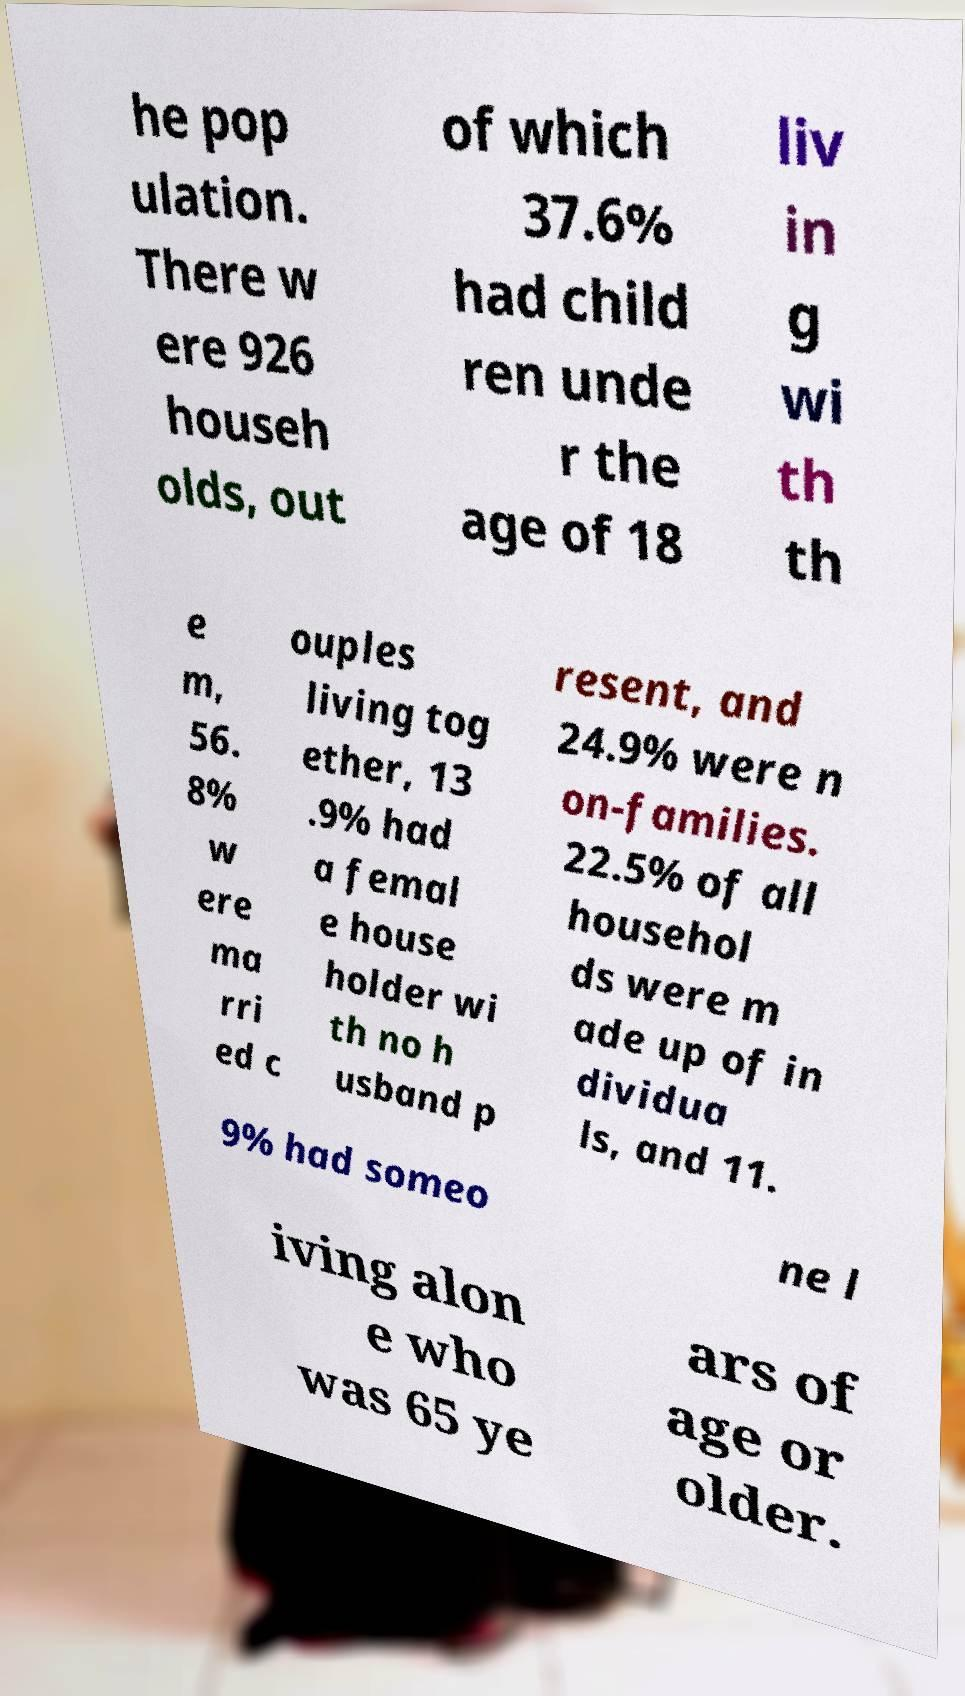Can you accurately transcribe the text from the provided image for me? he pop ulation. There w ere 926 househ olds, out of which 37.6% had child ren unde r the age of 18 liv in g wi th th e m, 56. 8% w ere ma rri ed c ouples living tog ether, 13 .9% had a femal e house holder wi th no h usband p resent, and 24.9% were n on-families. 22.5% of all househol ds were m ade up of in dividua ls, and 11. 9% had someo ne l iving alon e who was 65 ye ars of age or older. 